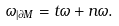Convert formula to latex. <formula><loc_0><loc_0><loc_500><loc_500>\omega _ { | \partial M } = t \omega + n \omega .</formula> 